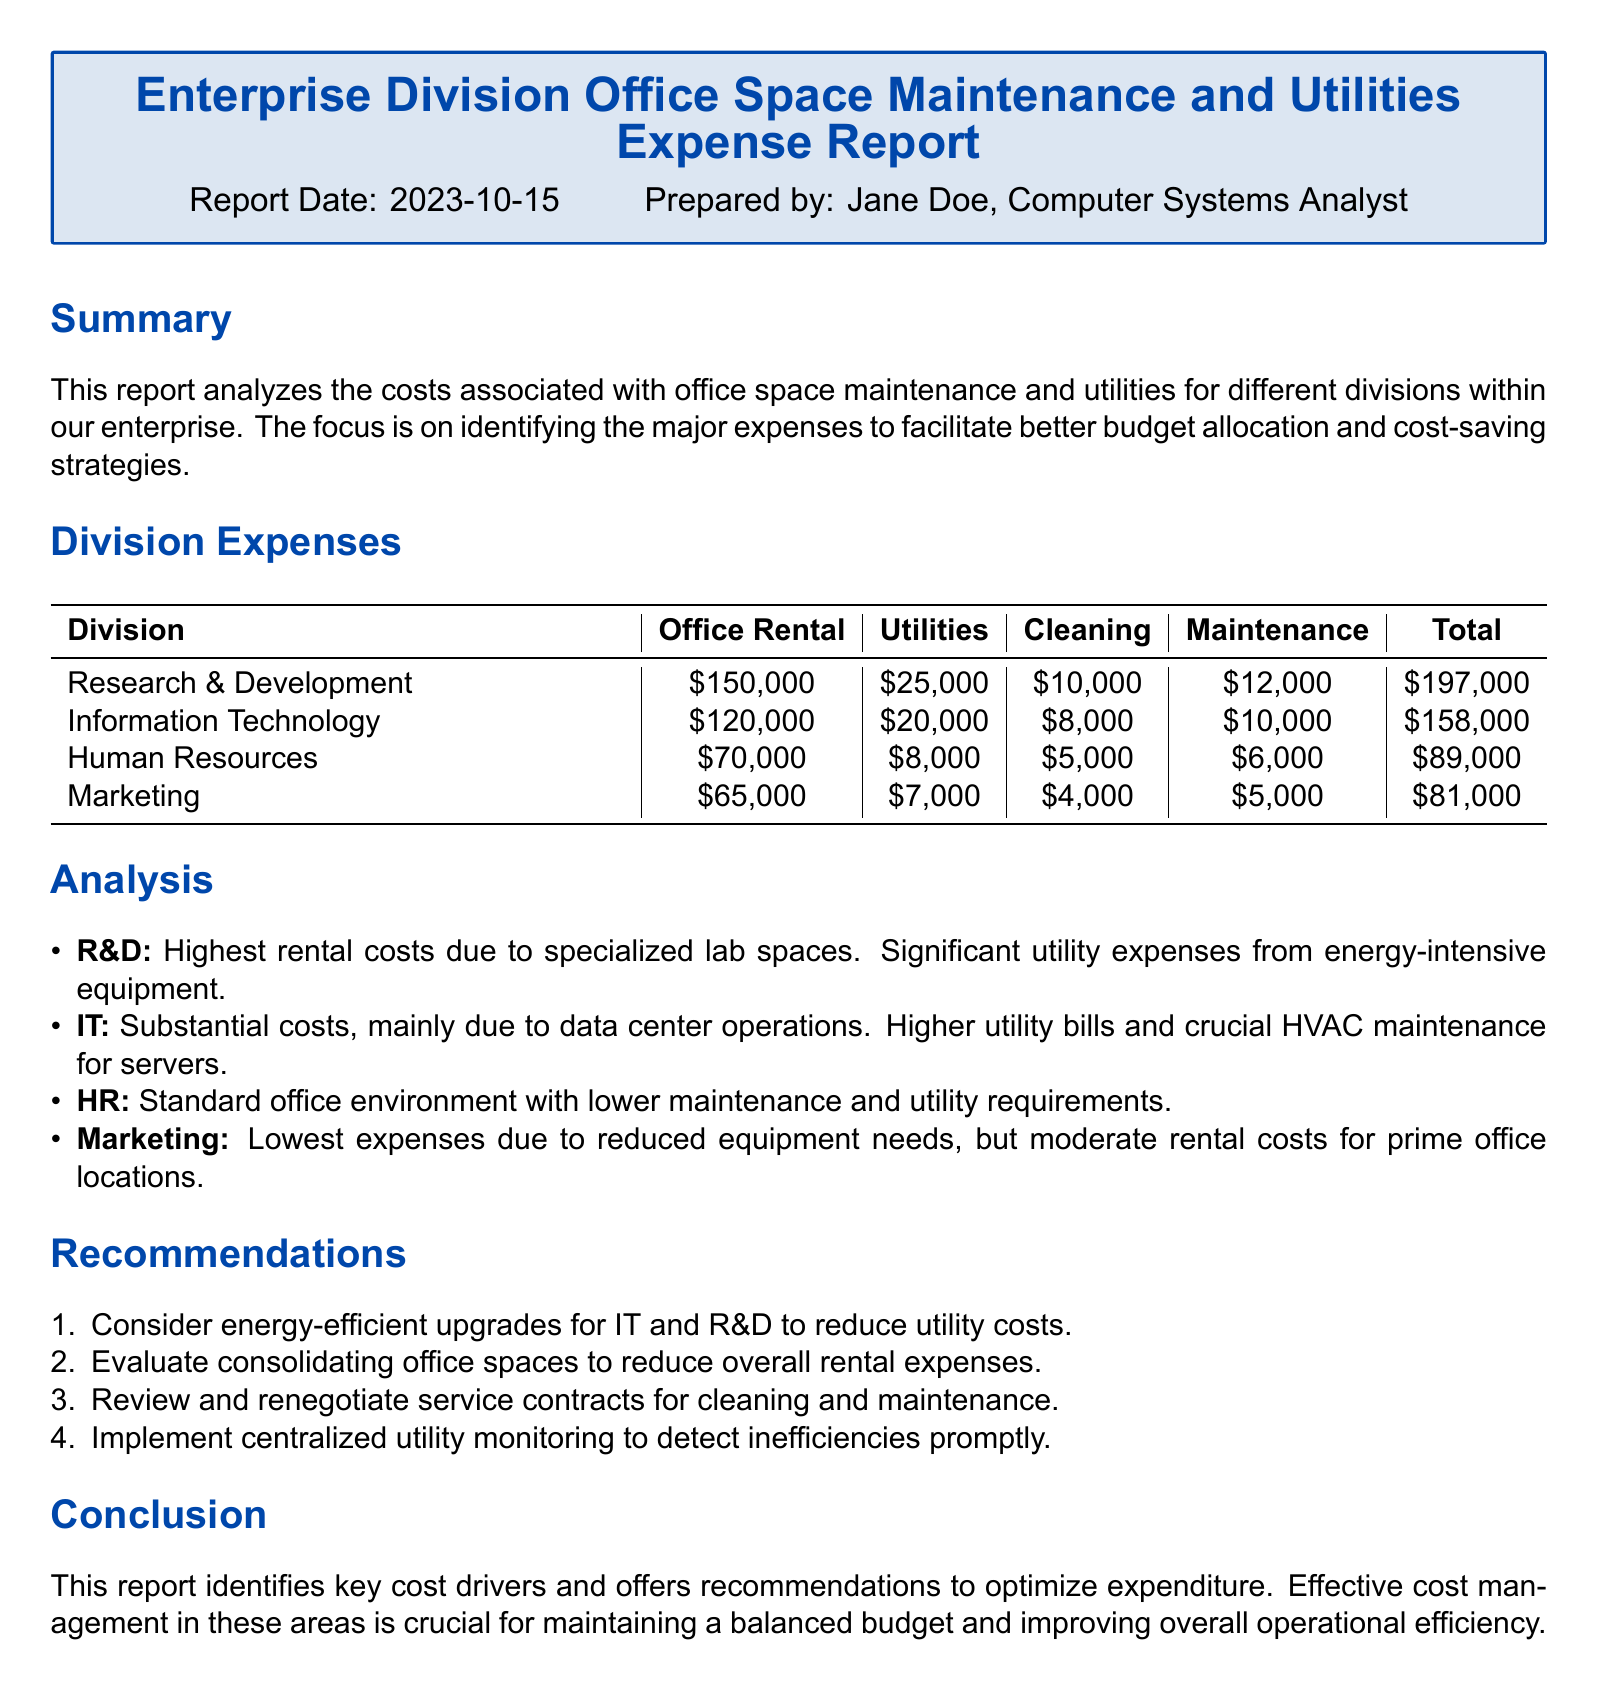What is the total expense for the Research & Development division? The total expense for the Research & Development division is found in the 'Total' column corresponding to that division, which is $197,000.
Answer: $197,000 What is the office rental cost for the Information Technology division? The office rental cost is available in the 'Office Rental' column for the Information Technology division, which is $120,000.
Answer: $120,000 What is the highest utility expense recorded? The highest utility expense is determined by comparing the values in the 'Utilities' column, which reveals that Research & Development has the highest at $25,000.
Answer: $25,000 Which division has the lowest total expenses? The division with the lowest total expenses is identified by comparing the 'Total' column entries, which indicates Marketing as the lowest at $81,000.
Answer: Marketing What recommendation involves energy efficiency? The recommendation regarding energy efficiency is specified as "Consider energy-efficient upgrades for IT and R&D to reduce utility costs."
Answer: Energy-efficient upgrades What is the major reason for high rental costs in R&D? The document states that the high rental costs in R&D are attributed to specialized lab spaces.
Answer: Specialized lab spaces How much does Human Resources spend on cleaning? The amount spent on cleaning by the Human Resources division is found in the 'Cleaning' column, which is $5,000.
Answer: $5,000 Which division faces substantial costs due to data center operations? The division facing substantial costs due to data center operations is deemed to be Information Technology as indicated in the analysis.
Answer: Information Technology What is the report's conclusion focused on? The report's conclusion focuses on identifying key cost drivers and offering recommendations to optimize expenditure.
Answer: Key cost drivers and recommendations 